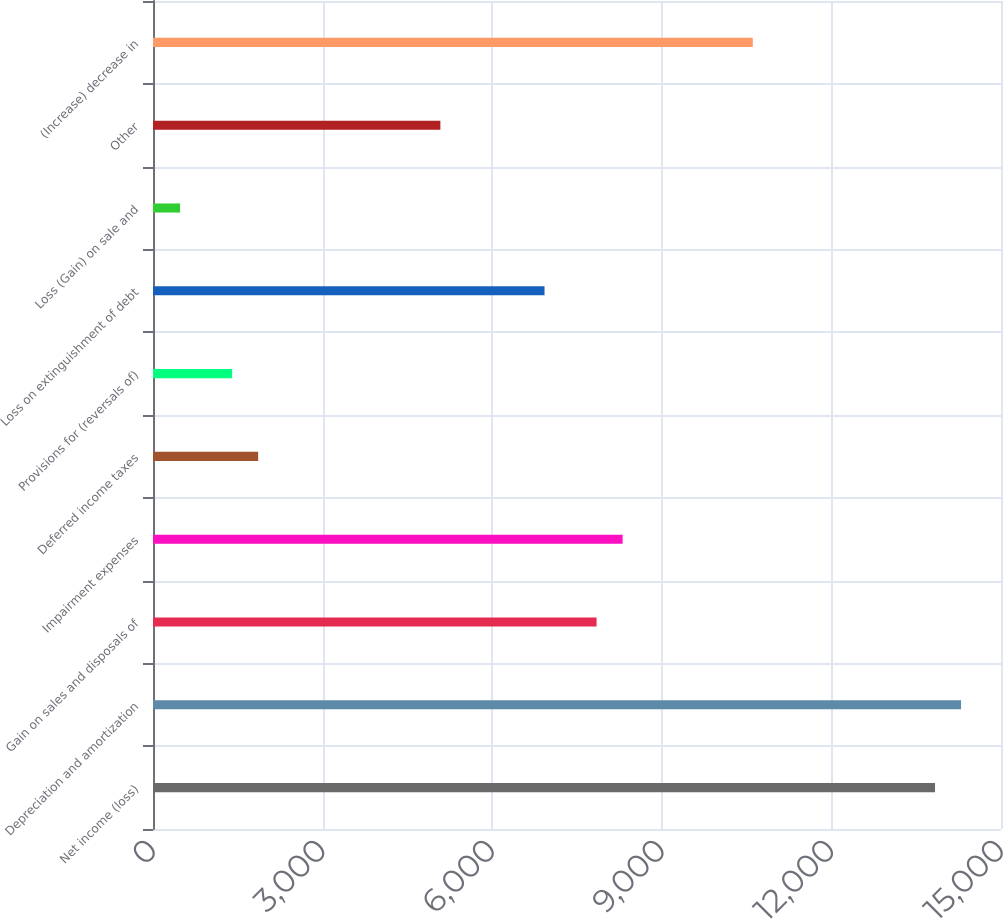Convert chart. <chart><loc_0><loc_0><loc_500><loc_500><bar_chart><fcel>Net income (loss)<fcel>Depreciation and amortization<fcel>Gain on sales and disposals of<fcel>Impairment expenses<fcel>Deferred income taxes<fcel>Provisions for (reversals of)<fcel>Loss on extinguishment of debt<fcel>Loss (Gain) on sale and<fcel>Other<fcel>(Increase) decrease in<nl><fcel>13833<fcel>14293.5<fcel>7846.5<fcel>8307<fcel>1860<fcel>1399.5<fcel>6925.5<fcel>478.5<fcel>5083.5<fcel>10609.5<nl></chart> 